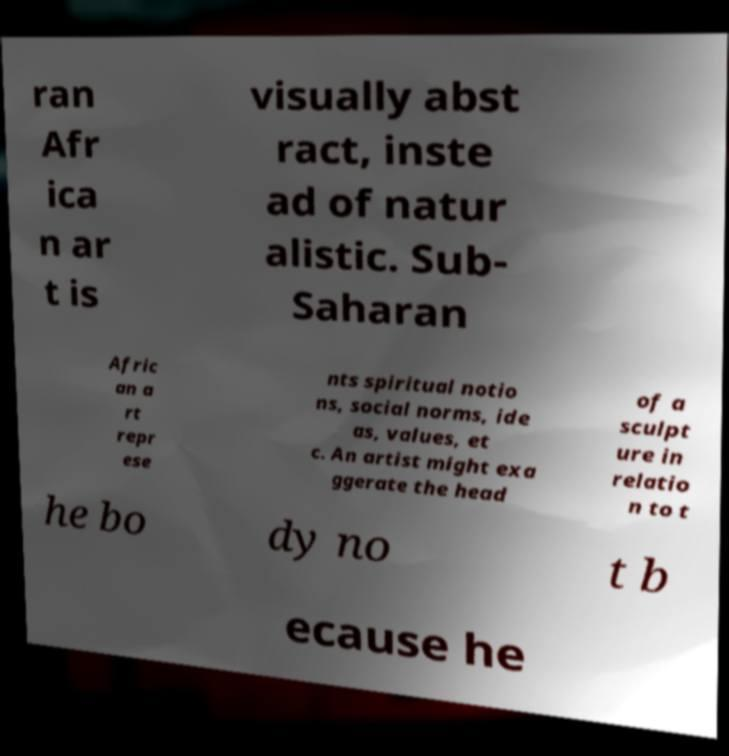There's text embedded in this image that I need extracted. Can you transcribe it verbatim? ran Afr ica n ar t is visually abst ract, inste ad of natur alistic. Sub- Saharan Afric an a rt repr ese nts spiritual notio ns, social norms, ide as, values, et c. An artist might exa ggerate the head of a sculpt ure in relatio n to t he bo dy no t b ecause he 